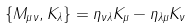<formula> <loc_0><loc_0><loc_500><loc_500>\{ M _ { \mu \nu } , K _ { \lambda } \} = \eta _ { \nu \lambda } K _ { \mu } - \eta _ { \lambda \mu } K _ { \nu }</formula> 